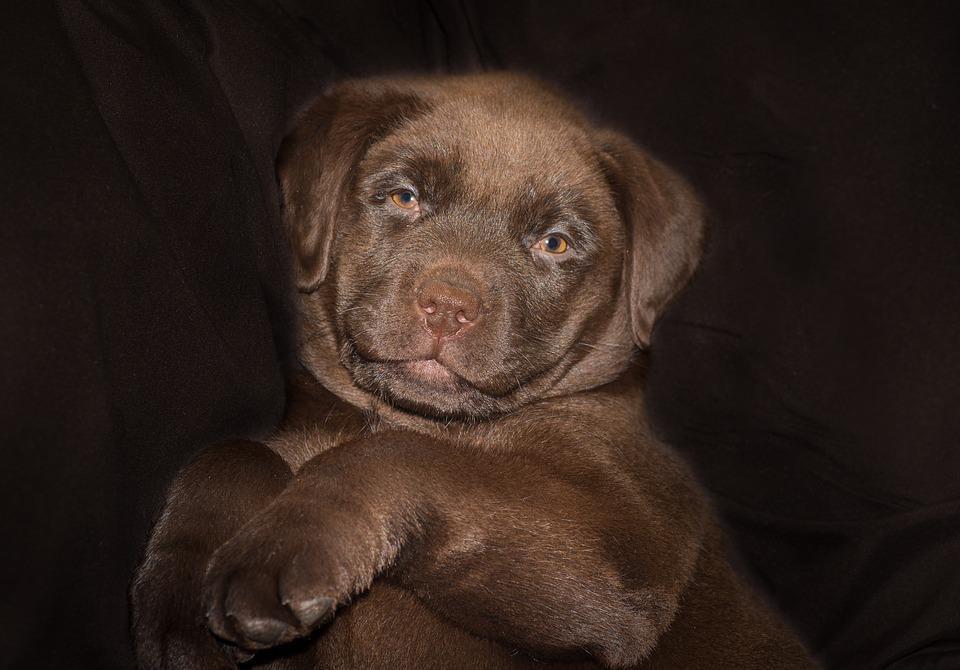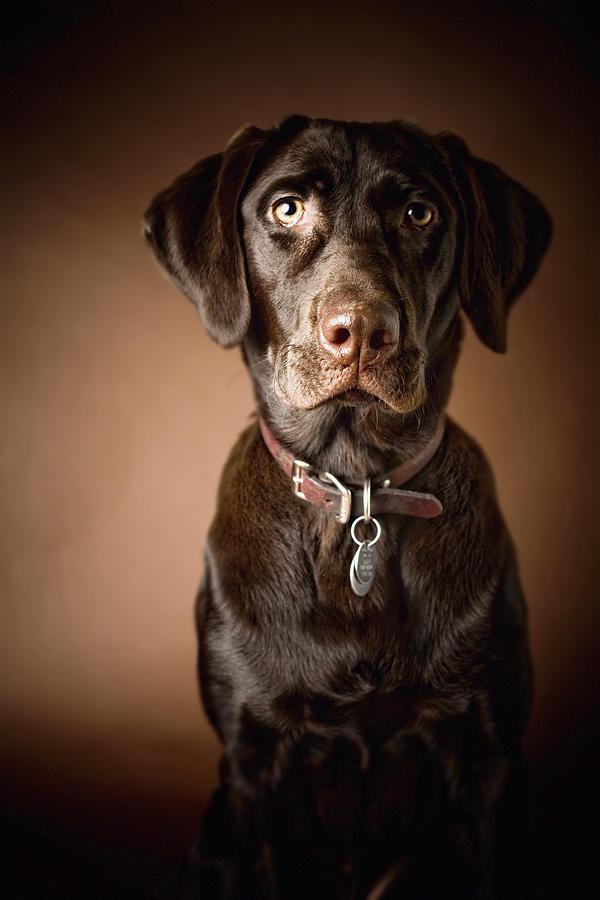The first image is the image on the left, the second image is the image on the right. Evaluate the accuracy of this statement regarding the images: "An image shows one young dog looking upward and to one side.". Is it true? Answer yes or no. No. The first image is the image on the left, the second image is the image on the right. Assess this claim about the two images: "The dog in the image on the left is not looking at the camera.". Correct or not? Answer yes or no. No. 